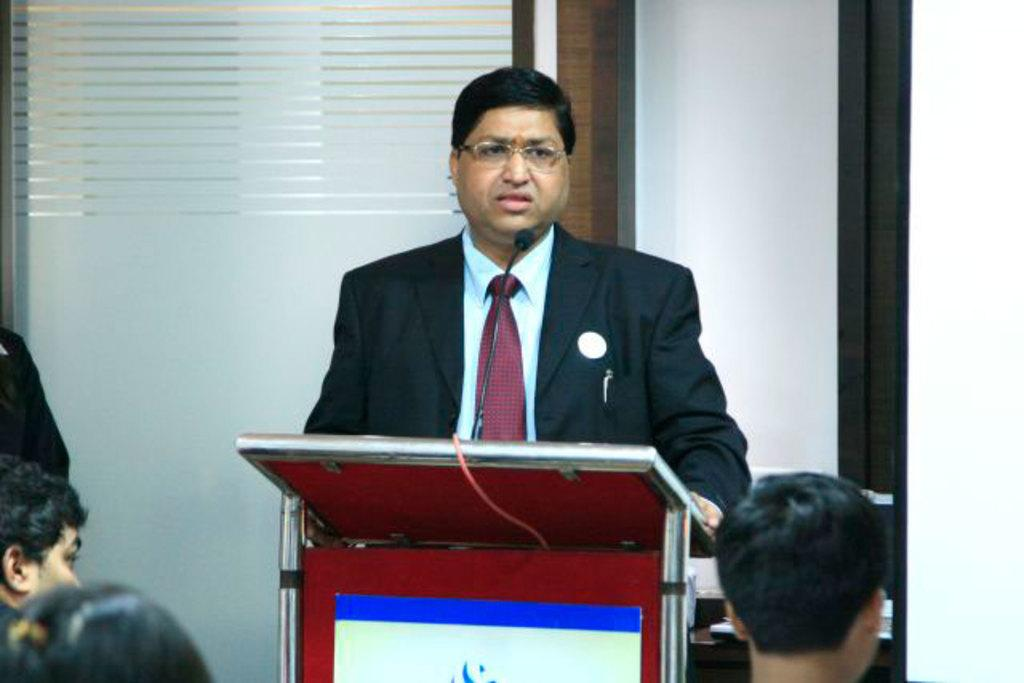Who is the main subject in the image? The main subject in the image is a man. What is the man doing in the image? The man is standing in front of a podium. Can you describe the man's attire in the image? The man is wearing a coat, a tie, and spectacles. Who else is present in the image? There are people in front of the man. What type of paper is the man holding in the image? There is no paper visible in the image. 